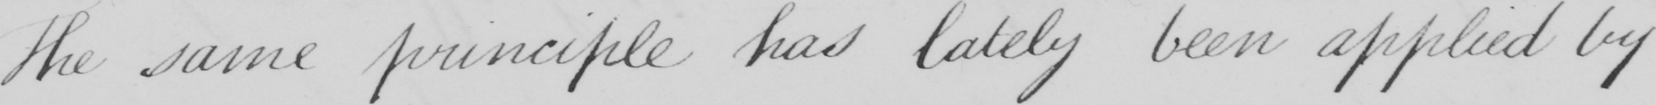Can you tell me what this handwritten text says? The same principle has lately been applied by 